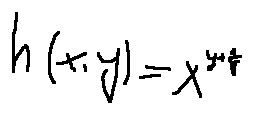Convert formula to latex. <formula><loc_0><loc_0><loc_500><loc_500>h ( x , y ) = x ^ { y + \frac { 1 } { y } }</formula> 